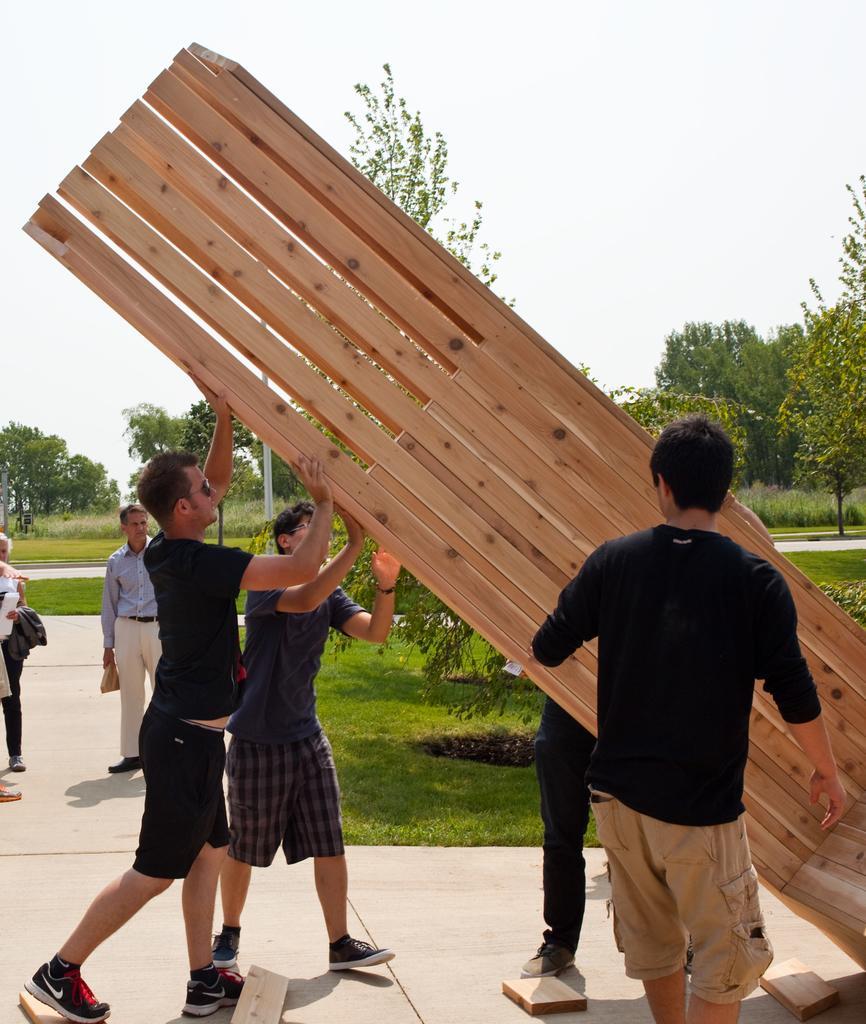In one or two sentences, can you explain what this image depicts? In this image we can see few persons and among them few persons are holding a wooden object. Behind the persons we can see the grass, trees and a pole. At the top we can see the sky. 